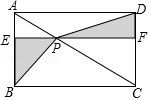How would you describe the relationship between the diagonals of the parallelogram? In a parallelogram like ABCD, the diagonals bisect each other. This means that point P, the intersection of the diagonals, is the midpoint of both AC and BD. Therefore, AP is equal to CP, and BP is equal to DP. These properties are often used in proofs within geometry to show relationships between angles and sides in parallelograms. What can you tell me about the angles formed where the diagonal meets the sides of the parallelogram? In a parallelogram, opposite angles are equal. Therefore, the angles formed where the diagonal AC meets the corners A and C are equal, and similarly, the angles at B and D are equal. Additionally, since diagonals bisect each other at point P, angles ∠APB and ∠CPD as well as angles ∠APD and ∠BPC are also equal. These equalities can have various implications in problem-solving related to parallelograms. 